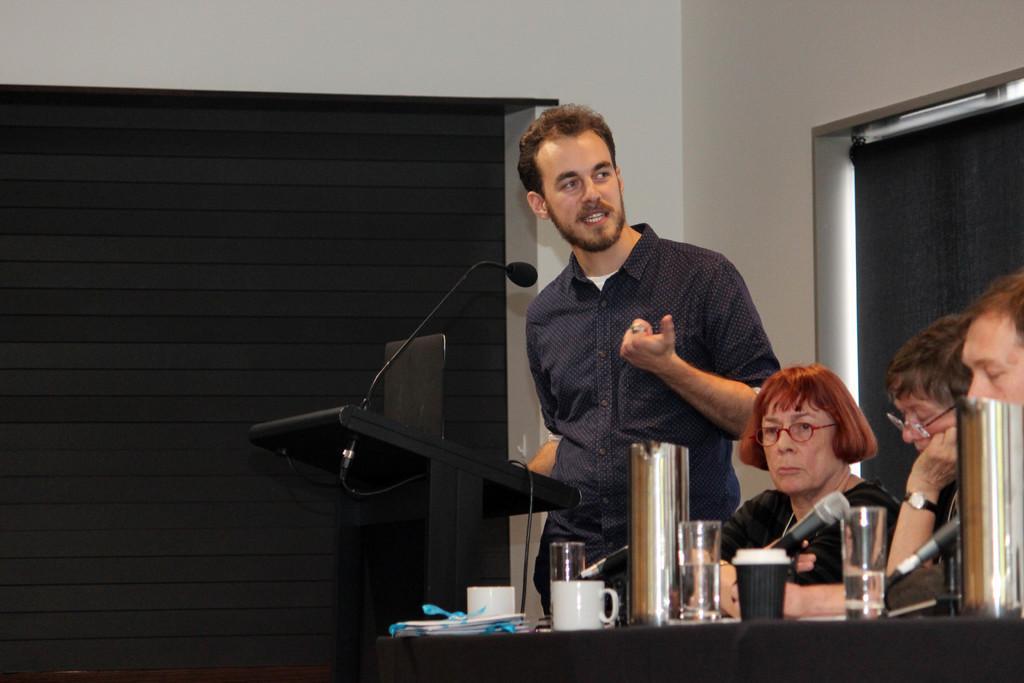Could you give a brief overview of what you see in this image? In the picture I can see a person standing and speaking in front of a mic which is placed on the stand and there are few persons sitting beside him and there is a table in front of them which has few mics,glass of water and some other objects on it. 